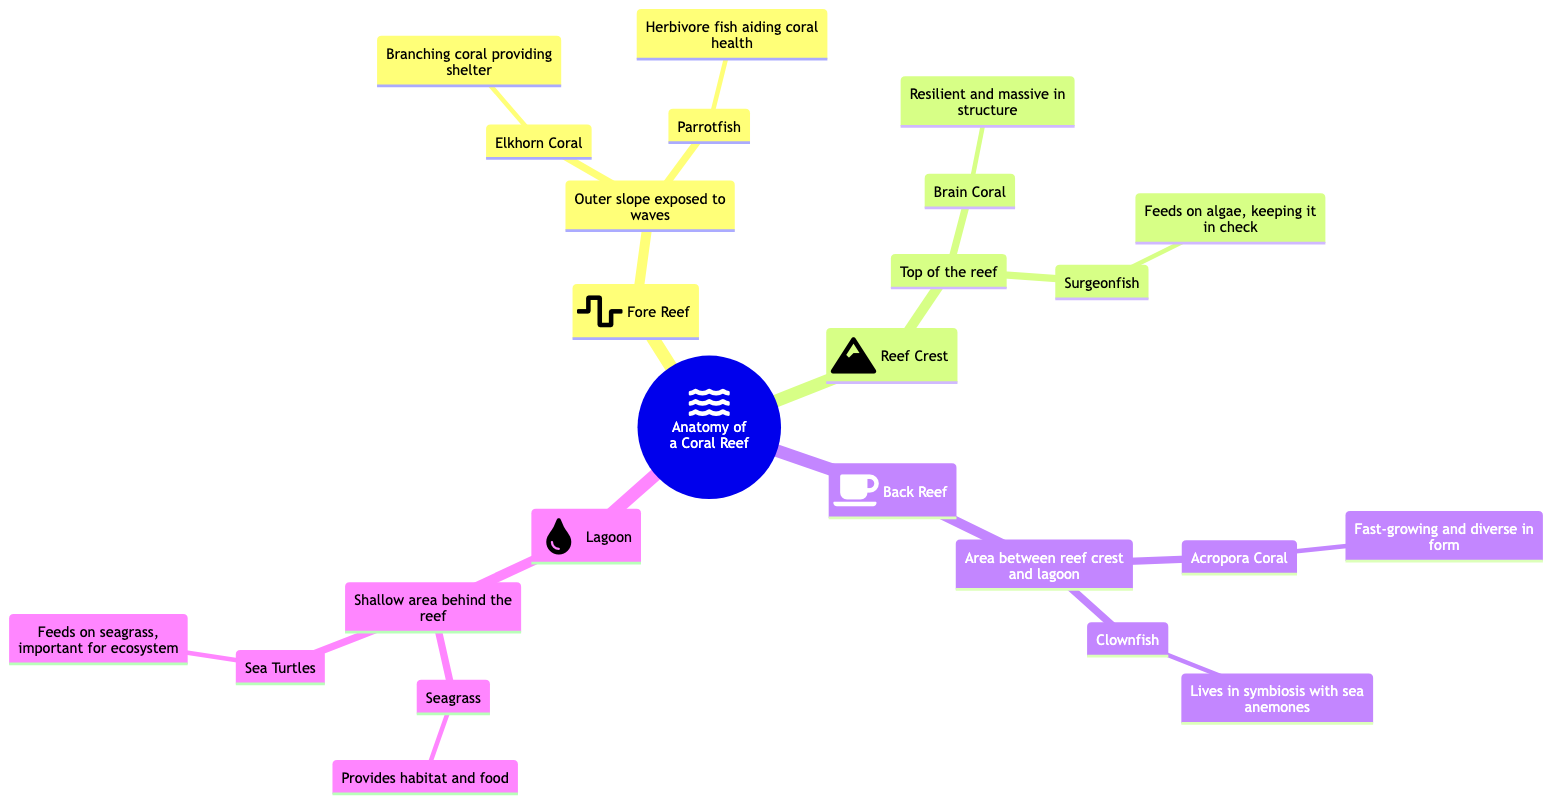What area is directly affected by waves? The diagram shows the "Fore Reef" section, which is specifically mentioned as being the outer slope exposed to waves.
Answer: Fore Reef Which coral is known for providing shelter? Under the "Fore Reef" section, the diagram states that "Elkhorn Coral" branches to provide shelter for inhabitants.
Answer: Elkhorn Coral What type of fish helps maintain coral health? The diagram notes "Parrotfish" as an herbivore fish that aids in coral health in the "Fore Reef" section.
Answer: Parrotfish Where do clownfish live in symbiosis? The diagram indicates that "Clownfish" live in symbiosis with "sea anemones" in the "Back Reef" area.
Answer: Sea anemones What is found in the lagoon that provides habitat and food? According to the "Lagoon" section of the diagram, "Seagrass" is what provides habitat and food.
Answer: Seagrass Which section is characterized by its resilient and massive coral structure? The "Reef Crest" section is highlighted in the diagram as being home to "Brain Coral," known for its resilient and massive structure.
Answer: Brain Coral How many inhabitants are listed under the Back Reef section? The diagram indicates that there are two inhabitants listed under the "Back Reef" section: "Acropora Coral" and "Clownfish."
Answer: 2 What type of fish helps keep algae in check? The diagram shows that "Surgeonfish," found in the "Reef Crest" area, feeds on algae, contributing to controlling its growth.
Answer: Surgeonfish What is the main feature of the lagoon area? The diagram describes the "Lagoon" as a shallow area behind the reef.
Answer: Shallow area 